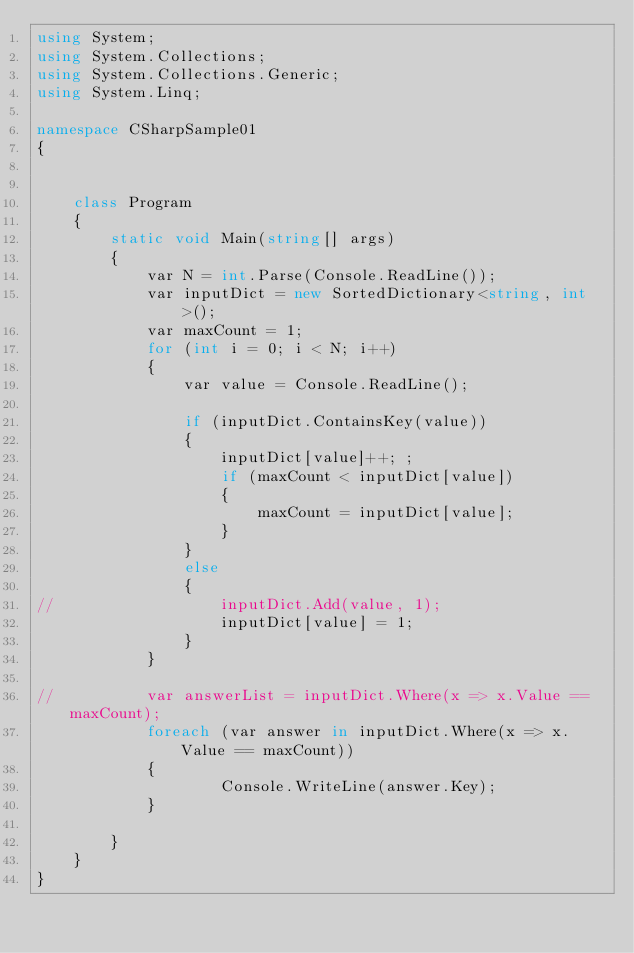Convert code to text. <code><loc_0><loc_0><loc_500><loc_500><_C#_>using System;
using System.Collections;
using System.Collections.Generic;
using System.Linq;

namespace CSharpSample01
{


	class Program
	{
		static void Main(string[] args)
		{
			var N = int.Parse(Console.ReadLine());
			var inputDict = new SortedDictionary<string, int>();
			var maxCount = 1;
			for (int i = 0; i < N; i++)
			{
				var value = Console.ReadLine();

				if (inputDict.ContainsKey(value))
				{
					inputDict[value]++; ;
					if (maxCount < inputDict[value])
					{
						maxCount = inputDict[value];
					}
				}
				else
				{
//					inputDict.Add(value, 1);
					inputDict[value] = 1;
				}
			}

//			var answerList = inputDict.Where(x => x.Value == maxCount);
			foreach (var answer in inputDict.Where(x => x.Value == maxCount))
			{
					Console.WriteLine(answer.Key);
			}

		}
	}
}</code> 